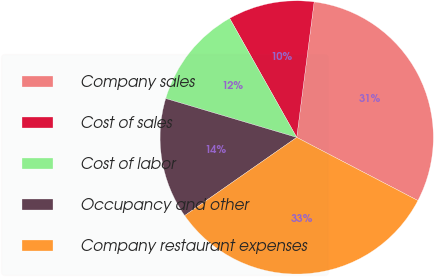Convert chart to OTSL. <chart><loc_0><loc_0><loc_500><loc_500><pie_chart><fcel>Company sales<fcel>Cost of sales<fcel>Cost of labor<fcel>Occupancy and other<fcel>Company restaurant expenses<nl><fcel>30.61%<fcel>10.2%<fcel>12.24%<fcel>14.29%<fcel>32.65%<nl></chart> 